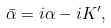<formula> <loc_0><loc_0><loc_500><loc_500>\bar { \alpha } = i \alpha - i K ^ { \prime } ,</formula> 